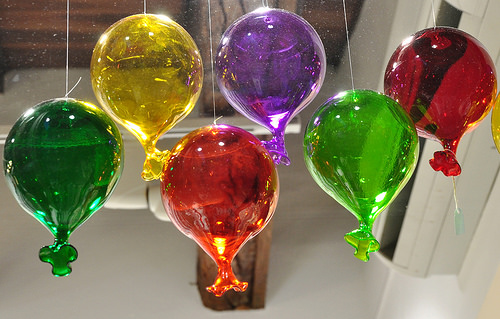<image>
Is the green balloon next to the yellow balloon? No. The green balloon is not positioned next to the yellow balloon. They are located in different areas of the scene. Is there a red baloon in front of the geen baloon? No. The red baloon is not in front of the geen baloon. The spatial positioning shows a different relationship between these objects. 